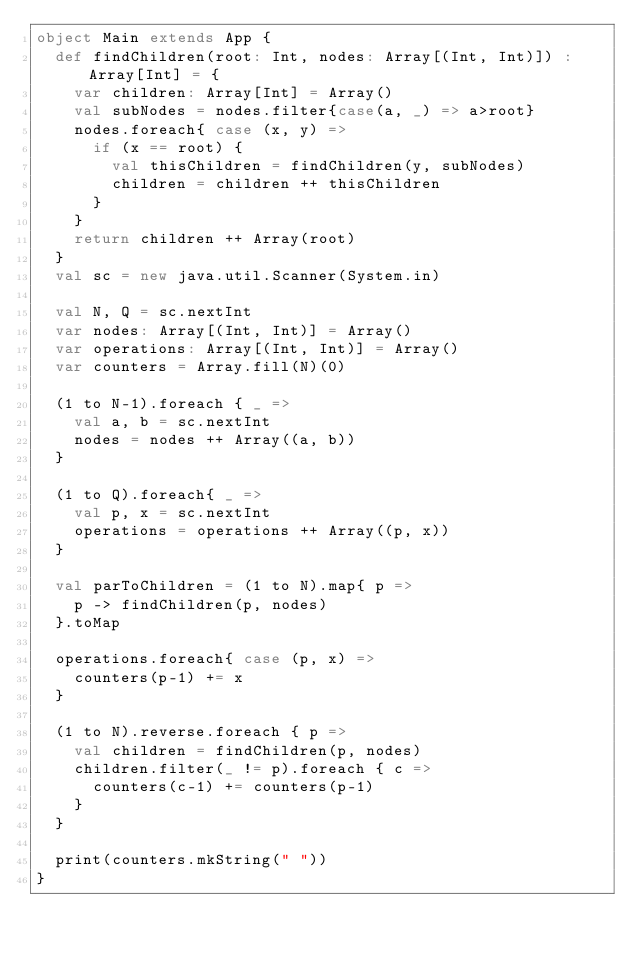Convert code to text. <code><loc_0><loc_0><loc_500><loc_500><_Scala_>object Main extends App {
  def findChildren(root: Int, nodes: Array[(Int, Int)]) : Array[Int] = {
    var children: Array[Int] = Array()
    val subNodes = nodes.filter{case(a, _) => a>root}
    nodes.foreach{ case (x, y) =>
      if (x == root) {
        val thisChildren = findChildren(y, subNodes)
        children = children ++ thisChildren
      }
    }
    return children ++ Array(root)
  }
  val sc = new java.util.Scanner(System.in)

  val N, Q = sc.nextInt
  var nodes: Array[(Int, Int)] = Array()
  var operations: Array[(Int, Int)] = Array()
  var counters = Array.fill(N)(0)

  (1 to N-1).foreach { _ =>
    val a, b = sc.nextInt
    nodes = nodes ++ Array((a, b))
  }

  (1 to Q).foreach{ _ =>
    val p, x = sc.nextInt
  	operations = operations ++ Array((p, x))
  }

  val parToChildren = (1 to N).map{ p =>
    p -> findChildren(p, nodes)
  }.toMap

  operations.foreach{ case (p, x) =>
    counters(p-1) += x
  }

  (1 to N).reverse.foreach { p =>
    val children = findChildren(p, nodes)
    children.filter(_ != p).foreach { c =>
      counters(c-1) += counters(p-1)
    }
  }

  print(counters.mkString(" "))
}</code> 